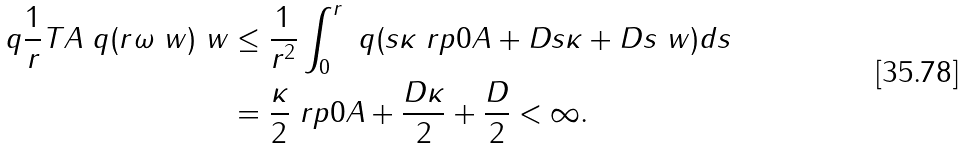Convert formula to latex. <formula><loc_0><loc_0><loc_500><loc_500>\ q \| \frac { 1 } { r } T A \ q ( r \omega \ w ) \ w \| & \leq \frac { 1 } { r ^ { 2 } } \int _ { 0 } ^ { r } \ q ( s \kappa \ r p { 0 } { A } + D s \kappa + D s \ w ) d s \\ & = \frac { \kappa } { 2 } \ r p { 0 } { A } + \frac { D \kappa } { 2 } + \frac { D } { 2 } < \infty .</formula> 